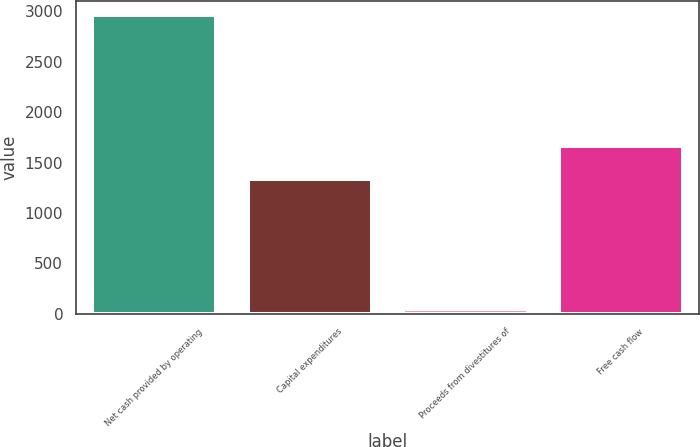<chart> <loc_0><loc_0><loc_500><loc_500><bar_chart><fcel>Net cash provided by operating<fcel>Capital expenditures<fcel>Proceeds from divestitures of<fcel>Free cash flow<nl><fcel>2960<fcel>1339<fcel>43<fcel>1664<nl></chart> 